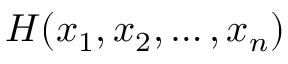<formula> <loc_0><loc_0><loc_500><loc_500>H ( x _ { 1 } , x _ { 2 } , \dots , x _ { n } )</formula> 